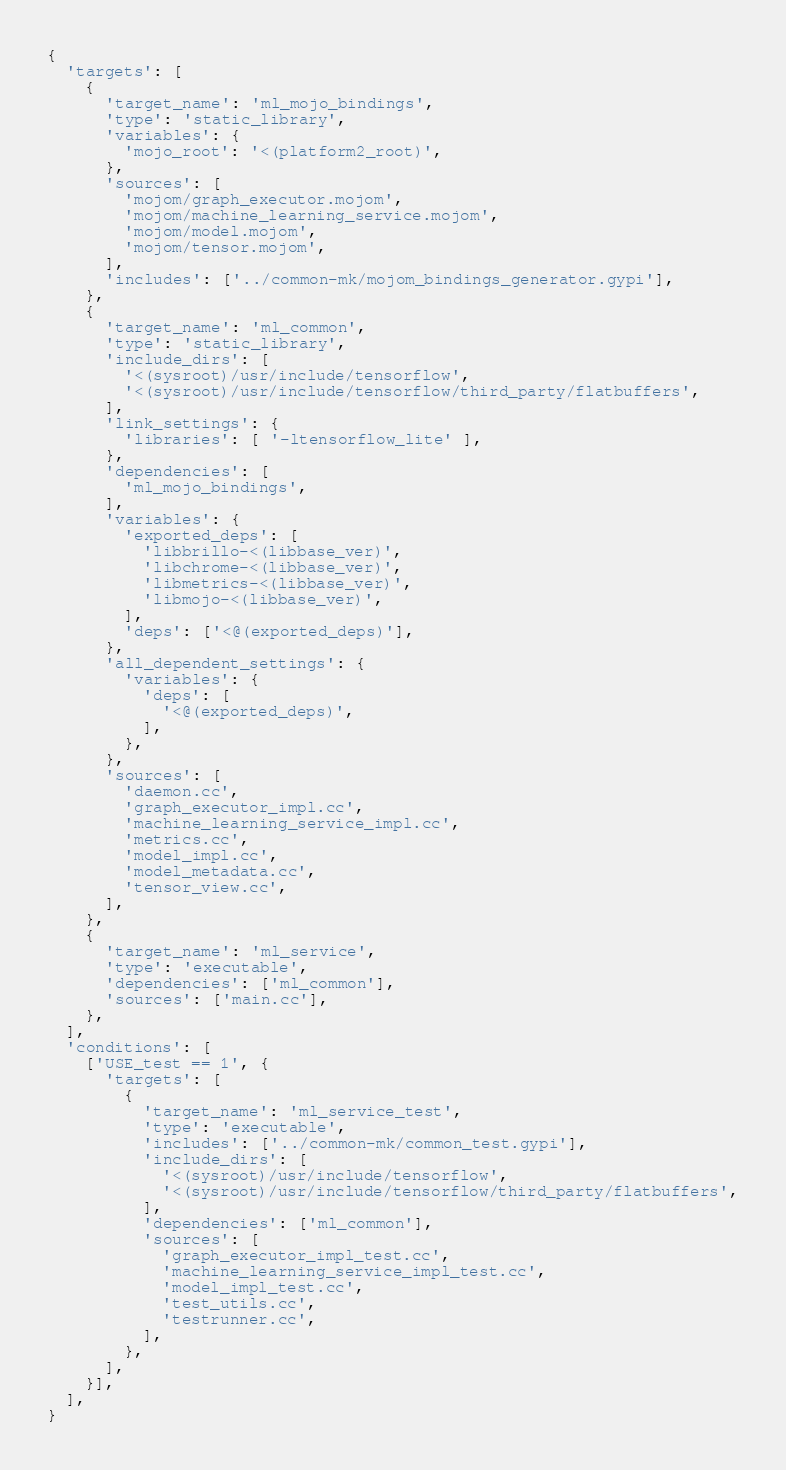<code> <loc_0><loc_0><loc_500><loc_500><_Python_>{
  'targets': [
    {
      'target_name': 'ml_mojo_bindings',
      'type': 'static_library',
      'variables': {
        'mojo_root': '<(platform2_root)',
      },
      'sources': [
        'mojom/graph_executor.mojom',
        'mojom/machine_learning_service.mojom',
        'mojom/model.mojom',
        'mojom/tensor.mojom',
      ],
      'includes': ['../common-mk/mojom_bindings_generator.gypi'],
    },
    {
      'target_name': 'ml_common',
      'type': 'static_library',
      'include_dirs': [
        '<(sysroot)/usr/include/tensorflow',
        '<(sysroot)/usr/include/tensorflow/third_party/flatbuffers',
      ],
      'link_settings': {
        'libraries': [ '-ltensorflow_lite' ],
      },
      'dependencies': [
        'ml_mojo_bindings',
      ],
      'variables': {
        'exported_deps': [
          'libbrillo-<(libbase_ver)',
          'libchrome-<(libbase_ver)',
          'libmetrics-<(libbase_ver)',
          'libmojo-<(libbase_ver)',
        ],
        'deps': ['<@(exported_deps)'],
      },
      'all_dependent_settings': {
        'variables': {
          'deps': [
            '<@(exported_deps)',
          ],
        },
      },
      'sources': [
        'daemon.cc',
        'graph_executor_impl.cc',
        'machine_learning_service_impl.cc',
        'metrics.cc',
        'model_impl.cc',
        'model_metadata.cc',
        'tensor_view.cc',
      ],
    },
    {
      'target_name': 'ml_service',
      'type': 'executable',
      'dependencies': ['ml_common'],
      'sources': ['main.cc'],
    },
  ],
  'conditions': [
    ['USE_test == 1', {
      'targets': [
        {
          'target_name': 'ml_service_test',
          'type': 'executable',
          'includes': ['../common-mk/common_test.gypi'],
          'include_dirs': [
            '<(sysroot)/usr/include/tensorflow',
            '<(sysroot)/usr/include/tensorflow/third_party/flatbuffers',
          ],
          'dependencies': ['ml_common'],
          'sources': [
            'graph_executor_impl_test.cc',
            'machine_learning_service_impl_test.cc',
            'model_impl_test.cc',
            'test_utils.cc',
            'testrunner.cc',
          ],
        },
      ],
    }],
  ],
}
</code> 